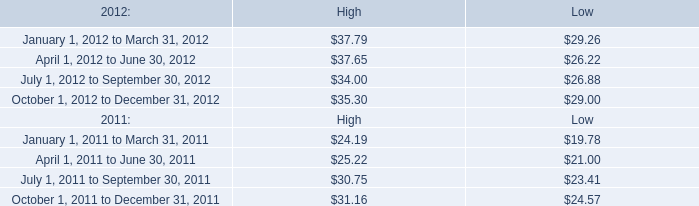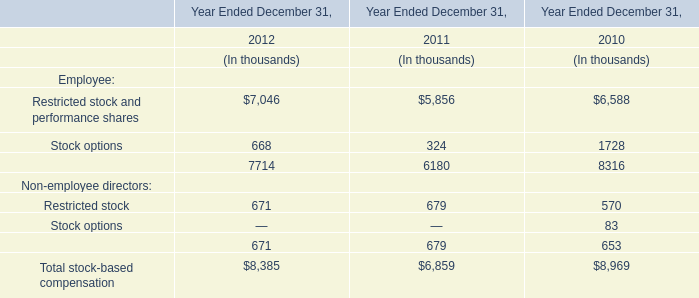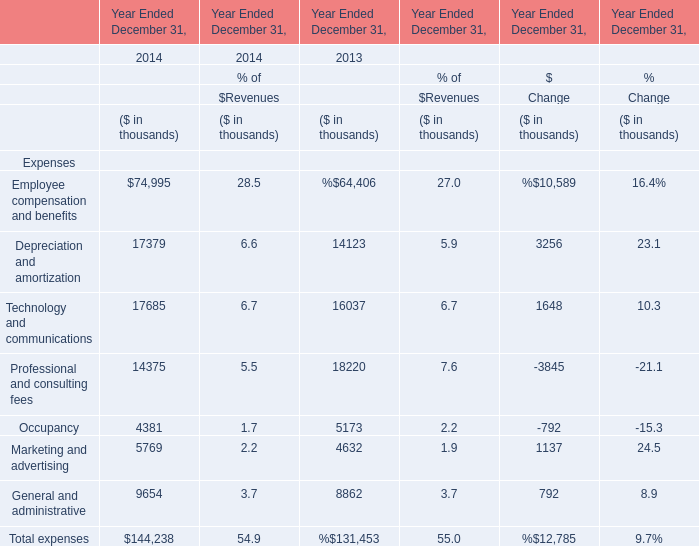What is the sum of Technology and communications and Professional and consulting fees in the range of 1000 and 20000 in 2014? 
Computations: (17685 + 14375)
Answer: 32060.0. 